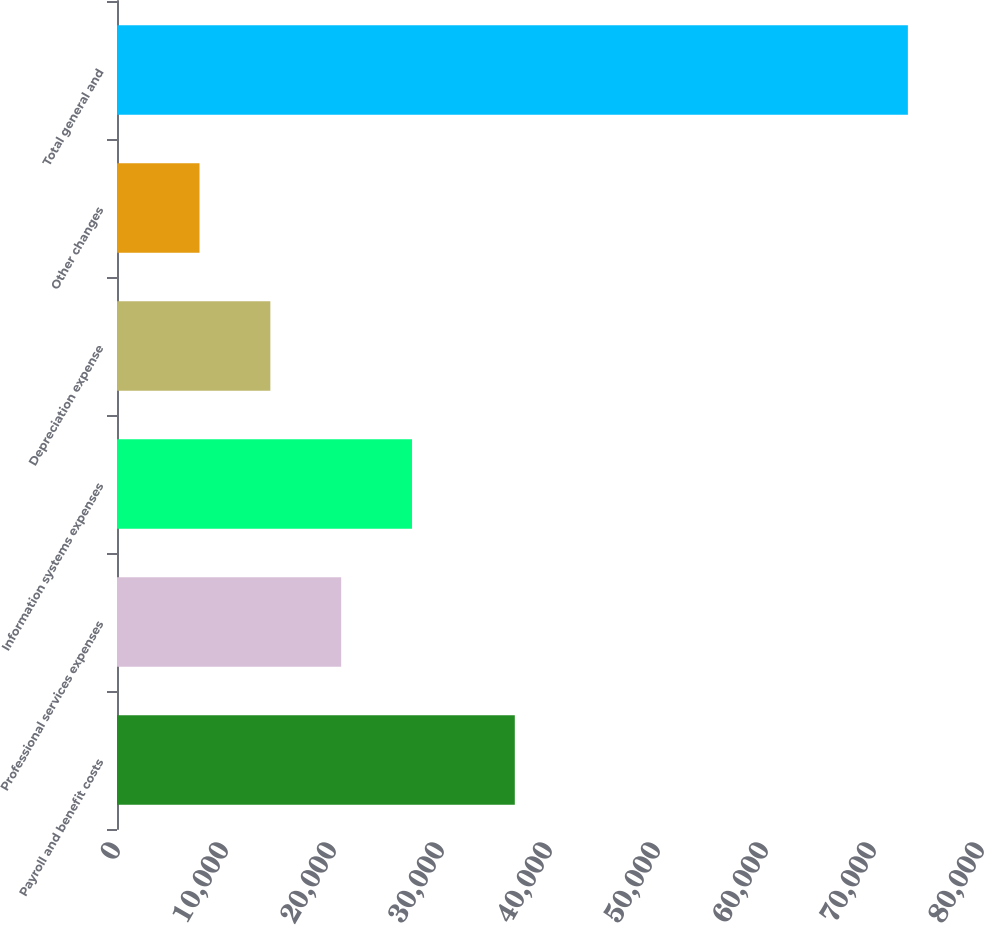<chart> <loc_0><loc_0><loc_500><loc_500><bar_chart><fcel>Payroll and benefit costs<fcel>Professional services expenses<fcel>Information systems expenses<fcel>Depreciation expense<fcel>Other changes<fcel>Total general and<nl><fcel>36833<fcel>20758.6<fcel>27317.4<fcel>14199.8<fcel>7641<fcel>73229<nl></chart> 